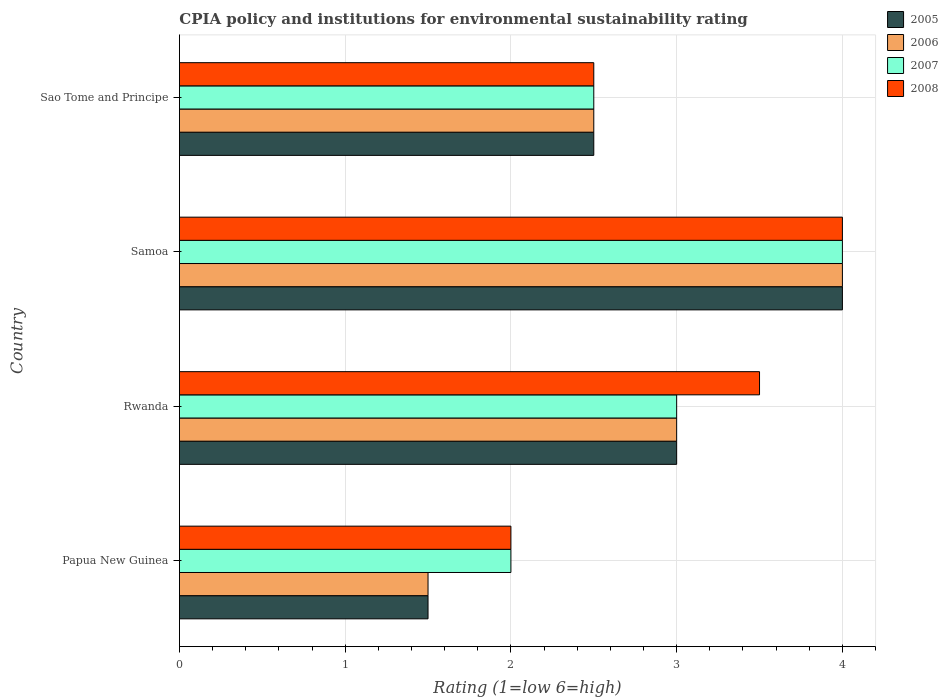How many groups of bars are there?
Ensure brevity in your answer.  4. What is the label of the 3rd group of bars from the top?
Make the answer very short. Rwanda. In how many cases, is the number of bars for a given country not equal to the number of legend labels?
Provide a succinct answer. 0. What is the CPIA rating in 2006 in Samoa?
Ensure brevity in your answer.  4. Across all countries, what is the minimum CPIA rating in 2005?
Offer a very short reply. 1.5. In which country was the CPIA rating in 2008 maximum?
Offer a terse response. Samoa. In which country was the CPIA rating in 2008 minimum?
Offer a very short reply. Papua New Guinea. What is the difference between the CPIA rating in 2007 in Papua New Guinea and that in Rwanda?
Offer a very short reply. -1. In how many countries, is the CPIA rating in 2006 greater than 3.8 ?
Provide a succinct answer. 1. Is the CPIA rating in 2006 in Rwanda less than that in Sao Tome and Principe?
Keep it short and to the point. No. What is the difference between the highest and the second highest CPIA rating in 2008?
Your answer should be compact. 0.5. What is the difference between the highest and the lowest CPIA rating in 2005?
Your answer should be compact. 2.5. Is it the case that in every country, the sum of the CPIA rating in 2007 and CPIA rating in 2008 is greater than the sum of CPIA rating in 2005 and CPIA rating in 2006?
Offer a very short reply. No. What does the 2nd bar from the top in Samoa represents?
Provide a short and direct response. 2007. How many bars are there?
Your answer should be compact. 16. How many countries are there in the graph?
Your answer should be compact. 4. What is the difference between two consecutive major ticks on the X-axis?
Give a very brief answer. 1. Are the values on the major ticks of X-axis written in scientific E-notation?
Keep it short and to the point. No. Does the graph contain any zero values?
Your answer should be very brief. No. Where does the legend appear in the graph?
Your response must be concise. Top right. What is the title of the graph?
Give a very brief answer. CPIA policy and institutions for environmental sustainability rating. Does "1971" appear as one of the legend labels in the graph?
Your answer should be very brief. No. What is the Rating (1=low 6=high) in 2005 in Papua New Guinea?
Keep it short and to the point. 1.5. What is the Rating (1=low 6=high) of 2006 in Papua New Guinea?
Make the answer very short. 1.5. What is the Rating (1=low 6=high) of 2007 in Papua New Guinea?
Your answer should be compact. 2. What is the Rating (1=low 6=high) of 2008 in Papua New Guinea?
Offer a terse response. 2. What is the Rating (1=low 6=high) in 2007 in Rwanda?
Provide a succinct answer. 3. What is the Rating (1=low 6=high) in 2008 in Rwanda?
Provide a succinct answer. 3.5. What is the Rating (1=low 6=high) in 2005 in Samoa?
Your response must be concise. 4. What is the Rating (1=low 6=high) of 2006 in Samoa?
Keep it short and to the point. 4. What is the Rating (1=low 6=high) of 2007 in Samoa?
Your answer should be very brief. 4. What is the Rating (1=low 6=high) of 2008 in Samoa?
Your response must be concise. 4. What is the Rating (1=low 6=high) of 2008 in Sao Tome and Principe?
Your answer should be compact. 2.5. Across all countries, what is the maximum Rating (1=low 6=high) of 2007?
Ensure brevity in your answer.  4. Across all countries, what is the maximum Rating (1=low 6=high) in 2008?
Give a very brief answer. 4. Across all countries, what is the minimum Rating (1=low 6=high) in 2007?
Your answer should be very brief. 2. Across all countries, what is the minimum Rating (1=low 6=high) of 2008?
Offer a very short reply. 2. What is the total Rating (1=low 6=high) in 2005 in the graph?
Offer a terse response. 11. What is the difference between the Rating (1=low 6=high) of 2005 in Papua New Guinea and that in Rwanda?
Ensure brevity in your answer.  -1.5. What is the difference between the Rating (1=low 6=high) of 2007 in Papua New Guinea and that in Rwanda?
Provide a short and direct response. -1. What is the difference between the Rating (1=low 6=high) in 2008 in Papua New Guinea and that in Rwanda?
Your answer should be very brief. -1.5. What is the difference between the Rating (1=low 6=high) in 2005 in Papua New Guinea and that in Samoa?
Make the answer very short. -2.5. What is the difference between the Rating (1=low 6=high) in 2006 in Papua New Guinea and that in Samoa?
Keep it short and to the point. -2.5. What is the difference between the Rating (1=low 6=high) of 2007 in Papua New Guinea and that in Samoa?
Ensure brevity in your answer.  -2. What is the difference between the Rating (1=low 6=high) of 2008 in Papua New Guinea and that in Samoa?
Make the answer very short. -2. What is the difference between the Rating (1=low 6=high) in 2005 in Papua New Guinea and that in Sao Tome and Principe?
Your answer should be compact. -1. What is the difference between the Rating (1=low 6=high) of 2007 in Papua New Guinea and that in Sao Tome and Principe?
Keep it short and to the point. -0.5. What is the difference between the Rating (1=low 6=high) of 2008 in Papua New Guinea and that in Sao Tome and Principe?
Offer a very short reply. -0.5. What is the difference between the Rating (1=low 6=high) of 2008 in Rwanda and that in Samoa?
Offer a terse response. -0.5. What is the difference between the Rating (1=low 6=high) in 2005 in Rwanda and that in Sao Tome and Principe?
Your answer should be compact. 0.5. What is the difference between the Rating (1=low 6=high) of 2007 in Rwanda and that in Sao Tome and Principe?
Ensure brevity in your answer.  0.5. What is the difference between the Rating (1=low 6=high) in 2005 in Samoa and that in Sao Tome and Principe?
Your answer should be compact. 1.5. What is the difference between the Rating (1=low 6=high) of 2005 in Papua New Guinea and the Rating (1=low 6=high) of 2007 in Rwanda?
Give a very brief answer. -1.5. What is the difference between the Rating (1=low 6=high) of 2006 in Papua New Guinea and the Rating (1=low 6=high) of 2007 in Rwanda?
Make the answer very short. -1.5. What is the difference between the Rating (1=low 6=high) in 2007 in Papua New Guinea and the Rating (1=low 6=high) in 2008 in Rwanda?
Ensure brevity in your answer.  -1.5. What is the difference between the Rating (1=low 6=high) in 2005 in Papua New Guinea and the Rating (1=low 6=high) in 2007 in Samoa?
Give a very brief answer. -2.5. What is the difference between the Rating (1=low 6=high) of 2006 in Papua New Guinea and the Rating (1=low 6=high) of 2008 in Samoa?
Ensure brevity in your answer.  -2.5. What is the difference between the Rating (1=low 6=high) of 2007 in Papua New Guinea and the Rating (1=low 6=high) of 2008 in Samoa?
Offer a terse response. -2. What is the difference between the Rating (1=low 6=high) of 2005 in Papua New Guinea and the Rating (1=low 6=high) of 2006 in Sao Tome and Principe?
Offer a terse response. -1. What is the difference between the Rating (1=low 6=high) in 2005 in Papua New Guinea and the Rating (1=low 6=high) in 2008 in Sao Tome and Principe?
Make the answer very short. -1. What is the difference between the Rating (1=low 6=high) of 2006 in Papua New Guinea and the Rating (1=low 6=high) of 2008 in Sao Tome and Principe?
Your answer should be compact. -1. What is the difference between the Rating (1=low 6=high) in 2006 in Rwanda and the Rating (1=low 6=high) in 2008 in Samoa?
Ensure brevity in your answer.  -1. What is the difference between the Rating (1=low 6=high) of 2005 in Rwanda and the Rating (1=low 6=high) of 2006 in Sao Tome and Principe?
Provide a succinct answer. 0.5. What is the difference between the Rating (1=low 6=high) of 2006 in Rwanda and the Rating (1=low 6=high) of 2008 in Sao Tome and Principe?
Keep it short and to the point. 0.5. What is the difference between the Rating (1=low 6=high) in 2007 in Rwanda and the Rating (1=low 6=high) in 2008 in Sao Tome and Principe?
Provide a succinct answer. 0.5. What is the difference between the Rating (1=low 6=high) of 2005 in Samoa and the Rating (1=low 6=high) of 2006 in Sao Tome and Principe?
Provide a succinct answer. 1.5. What is the difference between the Rating (1=low 6=high) in 2005 in Samoa and the Rating (1=low 6=high) in 2007 in Sao Tome and Principe?
Your answer should be very brief. 1.5. What is the difference between the Rating (1=low 6=high) of 2005 in Samoa and the Rating (1=low 6=high) of 2008 in Sao Tome and Principe?
Provide a short and direct response. 1.5. What is the difference between the Rating (1=low 6=high) of 2006 in Samoa and the Rating (1=low 6=high) of 2008 in Sao Tome and Principe?
Offer a terse response. 1.5. What is the average Rating (1=low 6=high) in 2005 per country?
Provide a succinct answer. 2.75. What is the average Rating (1=low 6=high) of 2006 per country?
Keep it short and to the point. 2.75. What is the average Rating (1=low 6=high) in 2007 per country?
Give a very brief answer. 2.88. What is the average Rating (1=low 6=high) of 2008 per country?
Ensure brevity in your answer.  3. What is the difference between the Rating (1=low 6=high) of 2005 and Rating (1=low 6=high) of 2008 in Papua New Guinea?
Offer a terse response. -0.5. What is the difference between the Rating (1=low 6=high) of 2006 and Rating (1=low 6=high) of 2007 in Papua New Guinea?
Provide a short and direct response. -0.5. What is the difference between the Rating (1=low 6=high) in 2005 and Rating (1=low 6=high) in 2006 in Rwanda?
Your response must be concise. 0. What is the difference between the Rating (1=low 6=high) in 2005 and Rating (1=low 6=high) in 2008 in Rwanda?
Offer a very short reply. -0.5. What is the difference between the Rating (1=low 6=high) in 2006 and Rating (1=low 6=high) in 2007 in Rwanda?
Offer a very short reply. 0. What is the difference between the Rating (1=low 6=high) in 2006 and Rating (1=low 6=high) in 2008 in Rwanda?
Make the answer very short. -0.5. What is the difference between the Rating (1=low 6=high) in 2005 and Rating (1=low 6=high) in 2006 in Samoa?
Offer a very short reply. 0. What is the difference between the Rating (1=low 6=high) of 2005 and Rating (1=low 6=high) of 2007 in Samoa?
Your answer should be compact. 0. What is the difference between the Rating (1=low 6=high) in 2006 and Rating (1=low 6=high) in 2007 in Samoa?
Offer a terse response. 0. What is the difference between the Rating (1=low 6=high) in 2006 and Rating (1=low 6=high) in 2008 in Samoa?
Ensure brevity in your answer.  0. What is the difference between the Rating (1=low 6=high) of 2007 and Rating (1=low 6=high) of 2008 in Samoa?
Your response must be concise. 0. What is the ratio of the Rating (1=low 6=high) in 2005 in Papua New Guinea to that in Rwanda?
Offer a very short reply. 0.5. What is the ratio of the Rating (1=low 6=high) in 2006 in Papua New Guinea to that in Rwanda?
Your answer should be very brief. 0.5. What is the ratio of the Rating (1=low 6=high) of 2005 in Papua New Guinea to that in Samoa?
Your answer should be compact. 0.38. What is the ratio of the Rating (1=low 6=high) in 2006 in Papua New Guinea to that in Samoa?
Provide a short and direct response. 0.38. What is the ratio of the Rating (1=low 6=high) of 2007 in Papua New Guinea to that in Samoa?
Provide a succinct answer. 0.5. What is the ratio of the Rating (1=low 6=high) in 2005 in Papua New Guinea to that in Sao Tome and Principe?
Make the answer very short. 0.6. What is the ratio of the Rating (1=low 6=high) in 2006 in Papua New Guinea to that in Sao Tome and Principe?
Ensure brevity in your answer.  0.6. What is the ratio of the Rating (1=low 6=high) of 2007 in Papua New Guinea to that in Sao Tome and Principe?
Your answer should be very brief. 0.8. What is the ratio of the Rating (1=low 6=high) of 2008 in Papua New Guinea to that in Sao Tome and Principe?
Ensure brevity in your answer.  0.8. What is the ratio of the Rating (1=low 6=high) of 2007 in Rwanda to that in Samoa?
Make the answer very short. 0.75. What is the ratio of the Rating (1=low 6=high) in 2008 in Rwanda to that in Samoa?
Your answer should be compact. 0.88. What is the ratio of the Rating (1=low 6=high) of 2007 in Rwanda to that in Sao Tome and Principe?
Give a very brief answer. 1.2. What is the ratio of the Rating (1=low 6=high) in 2006 in Samoa to that in Sao Tome and Principe?
Your answer should be compact. 1.6. What is the ratio of the Rating (1=low 6=high) of 2007 in Samoa to that in Sao Tome and Principe?
Provide a short and direct response. 1.6. What is the difference between the highest and the lowest Rating (1=low 6=high) in 2006?
Offer a very short reply. 2.5. What is the difference between the highest and the lowest Rating (1=low 6=high) in 2007?
Your answer should be very brief. 2. What is the difference between the highest and the lowest Rating (1=low 6=high) of 2008?
Offer a terse response. 2. 